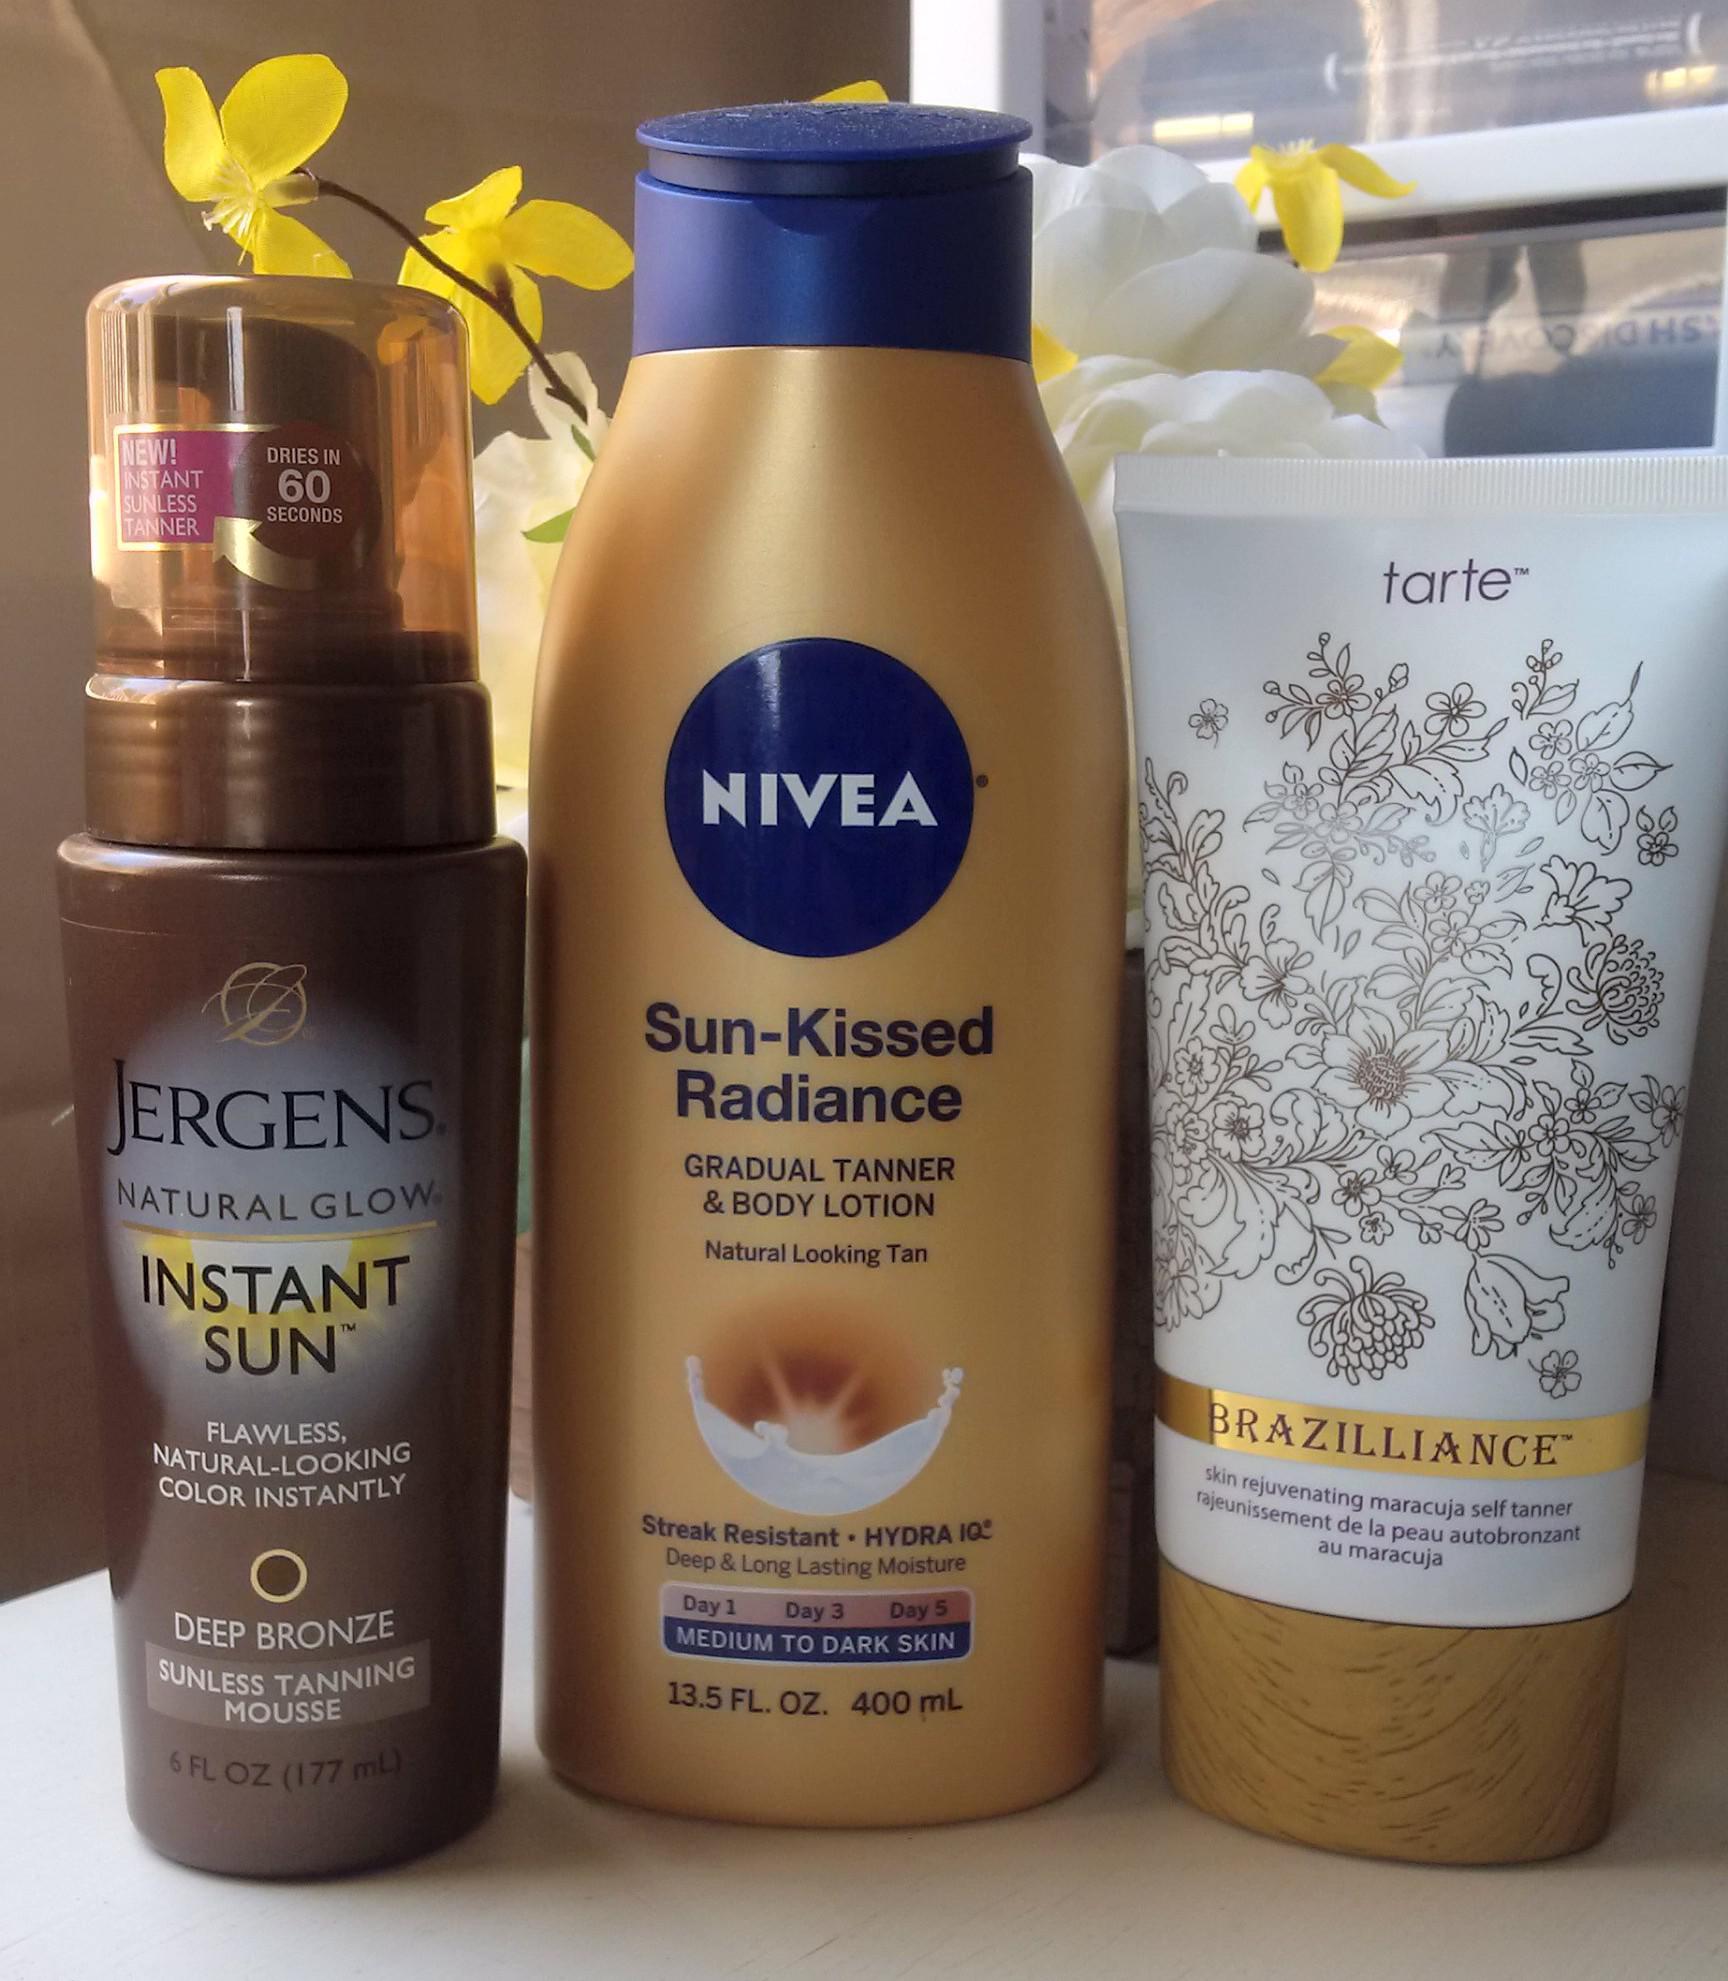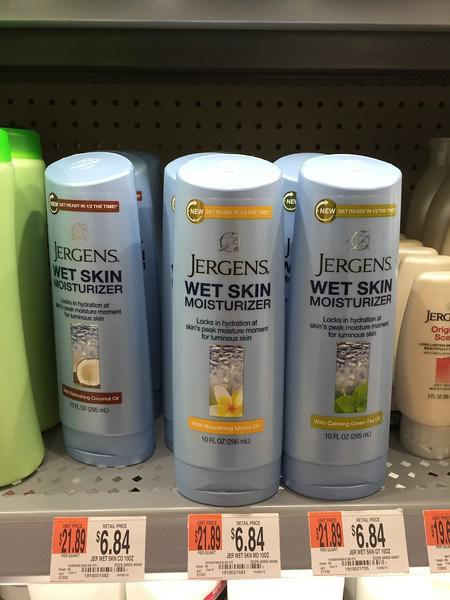The first image is the image on the left, the second image is the image on the right. Examine the images to the left and right. Is the description "Some items are on store shelves." accurate? Answer yes or no. Yes. The first image is the image on the left, the second image is the image on the right. Analyze the images presented: Is the assertion "In at least one image there is a row of three of the same brand moisturizer." valid? Answer yes or no. Yes. 